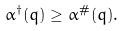<formula> <loc_0><loc_0><loc_500><loc_500>\alpha ^ { \dagger } ( q ) \geq \alpha ^ { \# } ( q ) .</formula> 